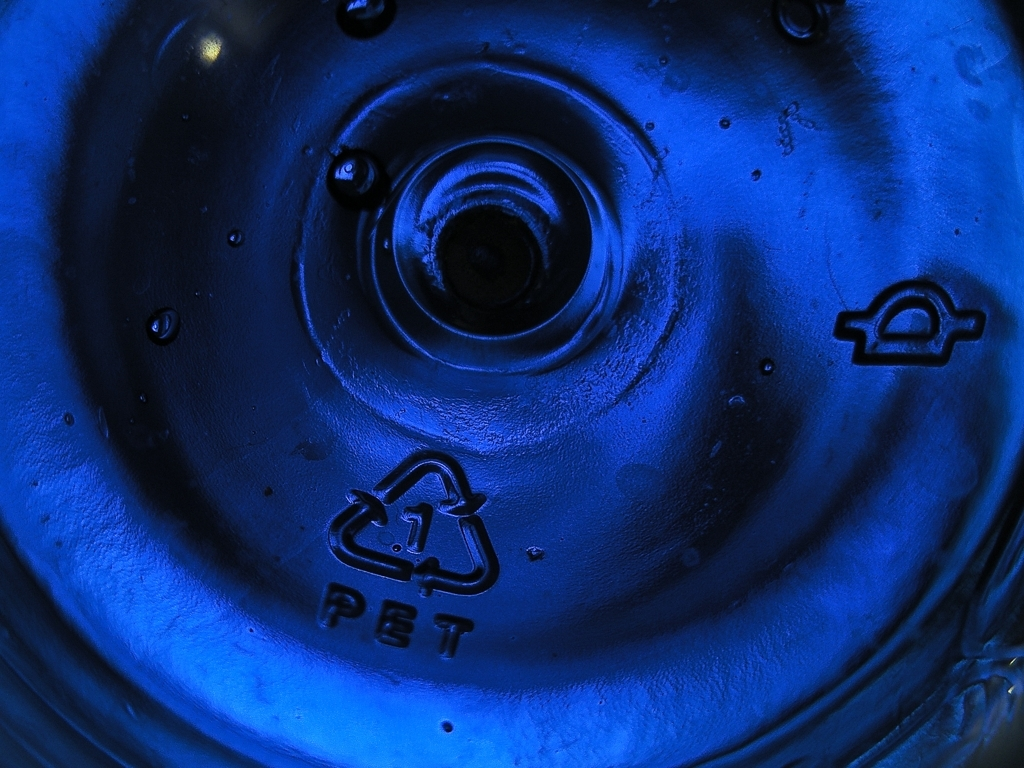Are there any noticeable artifacts in the image?
A. Yes
B. No
Answer with the option's letter from the given choices directly.
 B. 